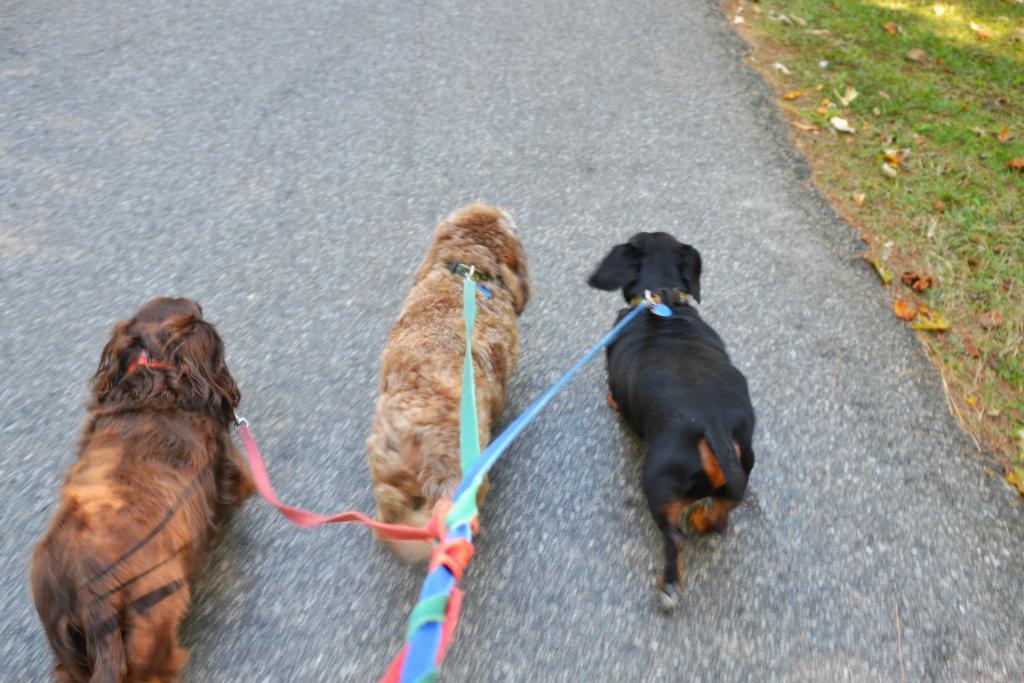In one or two sentences, can you explain what this image depicts? In this picture I can see leashes tied to the 3 dogs, which are on the road. On the right side of this picture I can see the grass, on which there are few leaves. 